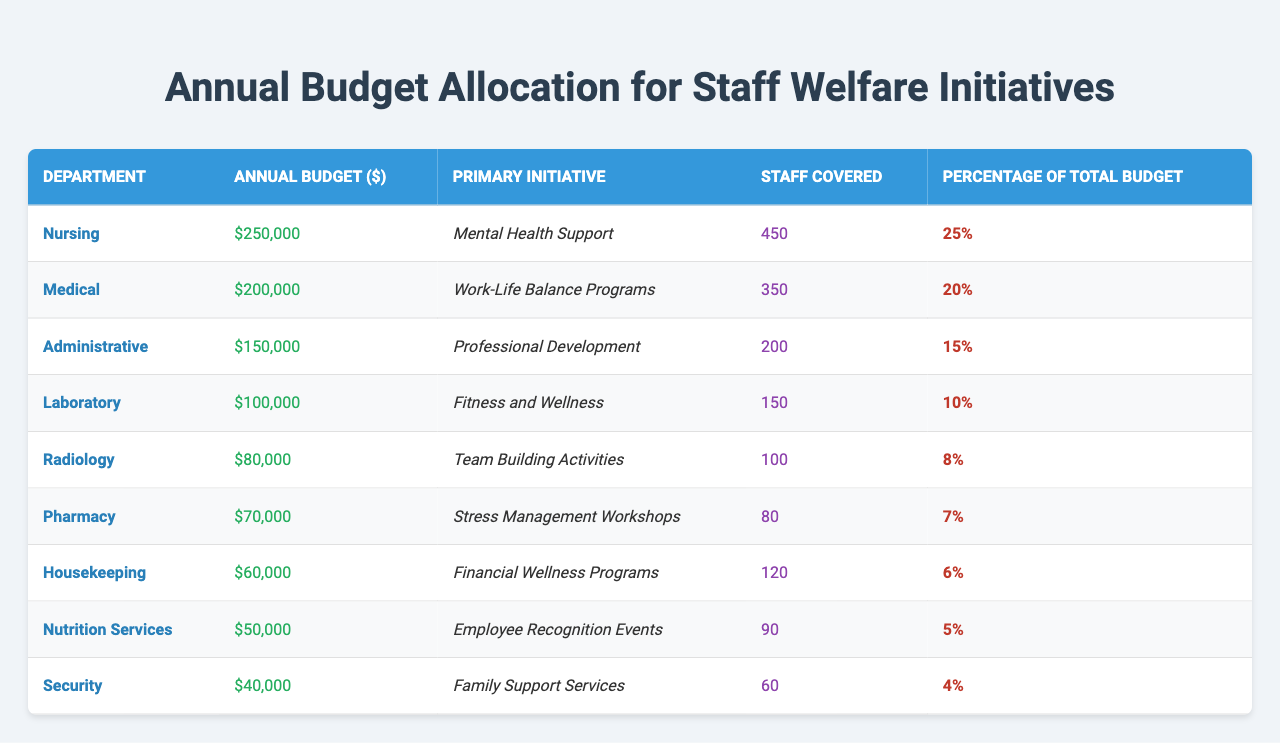What is the total annual budget allocation for staff welfare initiatives? By summing up the annual budget amounts for all departments: 250000 + 200000 + 150000 + 100000 + 80000 + 70000 + 60000 + 50000 + 40000 = 1,300,000.
Answer: 1,300,000 Which department has the highest budget allocated? The Nursing department has the highest allocation of $250,000, as indicated in the table under the "Annual Budget" column.
Answer: Nursing How many staff members are covered under the "Stress Management Workshops"? The table indicates that 80 staff members are covered under the "Stress Management Workshops" initiative in the Pharmacy department.
Answer: 80 What percentage of the total budget is allocated to "Mental Health Support"? The percentage for "Mental Health Support" in the Nursing department is 25%, directly given in the table under the "Percentage of Total Budget" column.
Answer: 25% Which initiative has the lowest budget allocation and what is the amount? The Security department has the lowest budget allocation of $40,000 for "Family Support Services." This is the smallest amount in the "Annual Budget" column.
Answer: $40,000 What is the total number of staff members covered across all departments? By summing staff members covered across departments: 450 + 350 + 200 + 150 + 100 + 80 + 120 + 90 + 60 = 1,600.
Answer: 1,600 True or False: The Laboratory department has a budget allocation greater than the Pharmacy department. The Laboratory's budget is $100,000, while the Pharmacy's budget is $70,000, confirming that the Laboratory's allocation is greater.
Answer: True If we consider the top three initiatives by budget, what is their combined budget? The top three budgets are for Nursing ($250,000), Medical ($200,000), and Administrative ($150,000). The combined total is 250000 + 200000 + 150000 = 600000.
Answer: 600,000 What is the difference between the budget allocation of the Administrative and Housekeeping departments? The Administrative department's budget is $150,000 and Housekeeping's budget is $60,000. The difference is 150000 - 60000 = 90000.
Answer: 90,000 Which department covers the highest number of staff members and what is the number? The Nursing department covers the highest number of staff members with 450, as shown in the "Staff Covered" column.
Answer: 450 